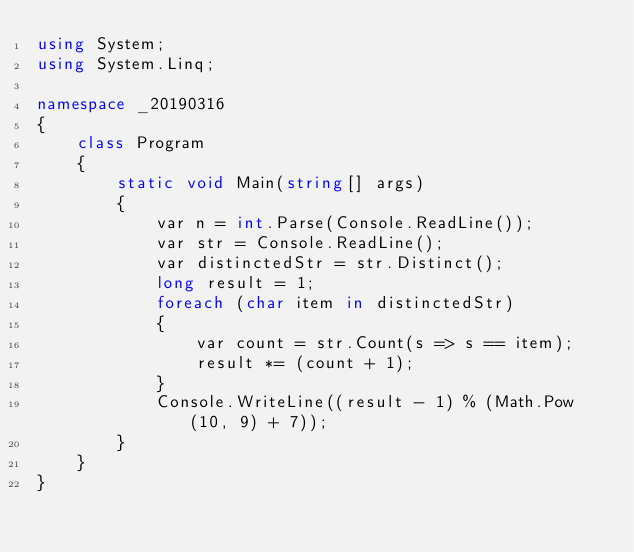<code> <loc_0><loc_0><loc_500><loc_500><_C#_>using System;
using System.Linq;

namespace _20190316
{
    class Program
    {
        static void Main(string[] args)
        {
            var n = int.Parse(Console.ReadLine());
            var str = Console.ReadLine();
            var distinctedStr = str.Distinct();
            long result = 1;
            foreach (char item in distinctedStr)
            {
                var count = str.Count(s => s == item);
                result *= (count + 1);
            }
            Console.WriteLine((result - 1) % (Math.Pow(10, 9) + 7));
        }
    }
}
</code> 